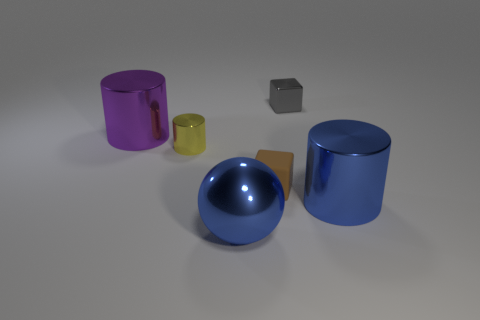Do the gray cube and the matte cube have the same size?
Provide a short and direct response. Yes. There is a small object that is made of the same material as the tiny yellow cylinder; what is its shape?
Offer a very short reply. Cube. How many other objects are there of the same shape as the yellow thing?
Make the answer very short. 2. What is the shape of the tiny yellow object behind the big shiny cylinder that is in front of the big metal object that is to the left of the blue shiny ball?
Your response must be concise. Cylinder. What number of cylinders are small objects or small gray things?
Give a very brief answer. 1. There is a big metallic cylinder in front of the large purple cylinder; are there any rubber blocks that are in front of it?
Give a very brief answer. No. Are there any other things that are the same material as the brown thing?
Ensure brevity in your answer.  No. Is the shape of the tiny brown object the same as the gray metal thing that is to the left of the big blue cylinder?
Provide a succinct answer. Yes. How many other objects are the same size as the blue ball?
Ensure brevity in your answer.  2. What number of green objects are either metal objects or tiny rubber balls?
Provide a short and direct response. 0. 